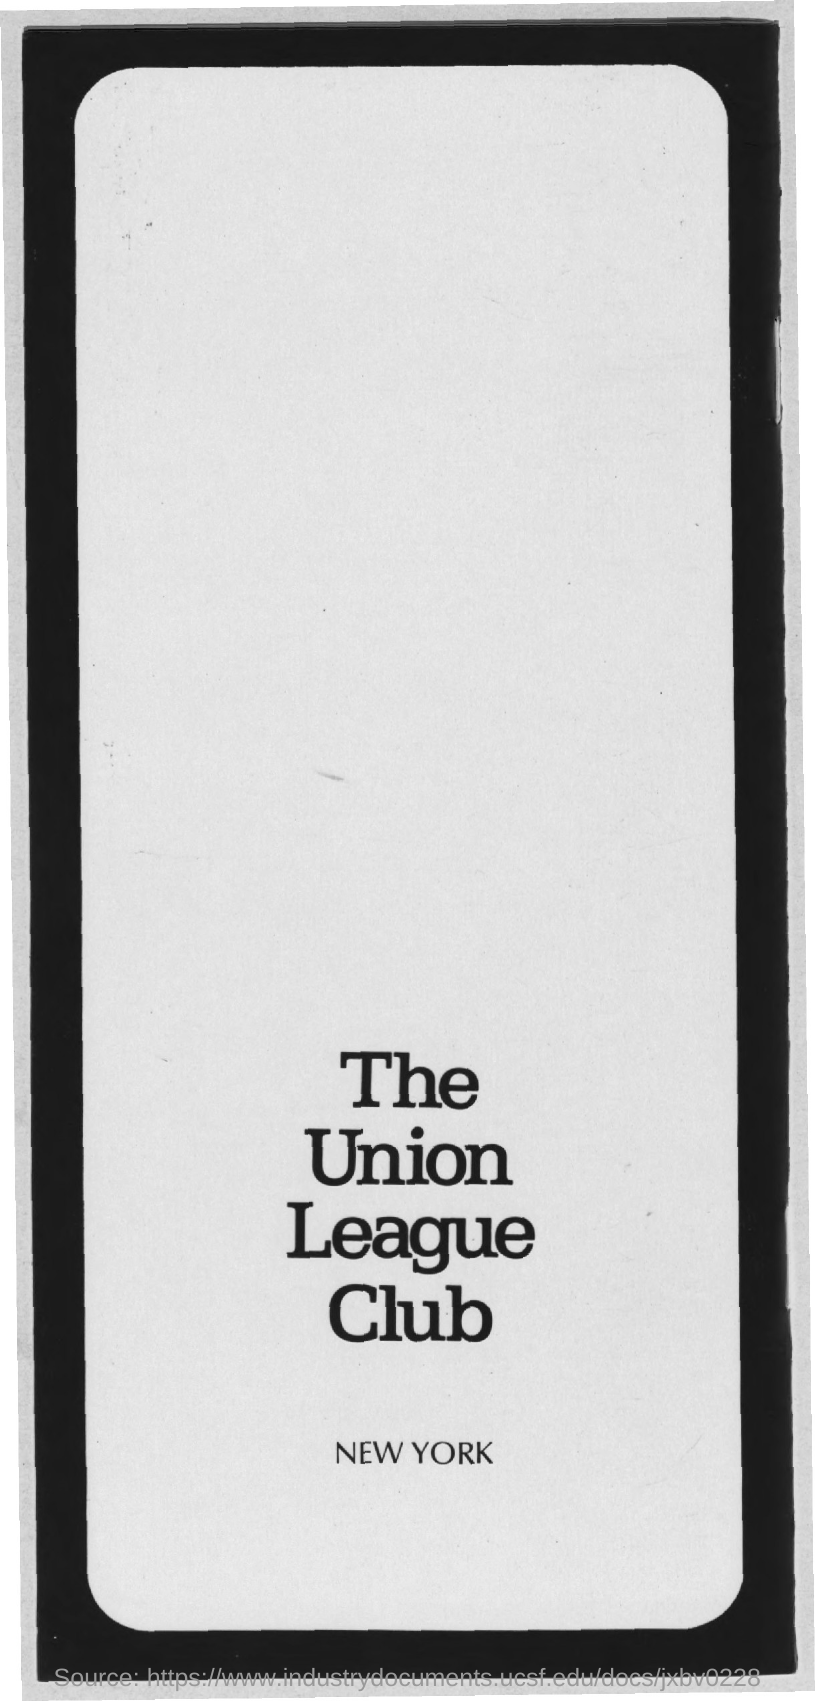Highlight a few significant elements in this photo. The place mentioned in the document is New York. What is the title of the document? It is called The Union League Club. 